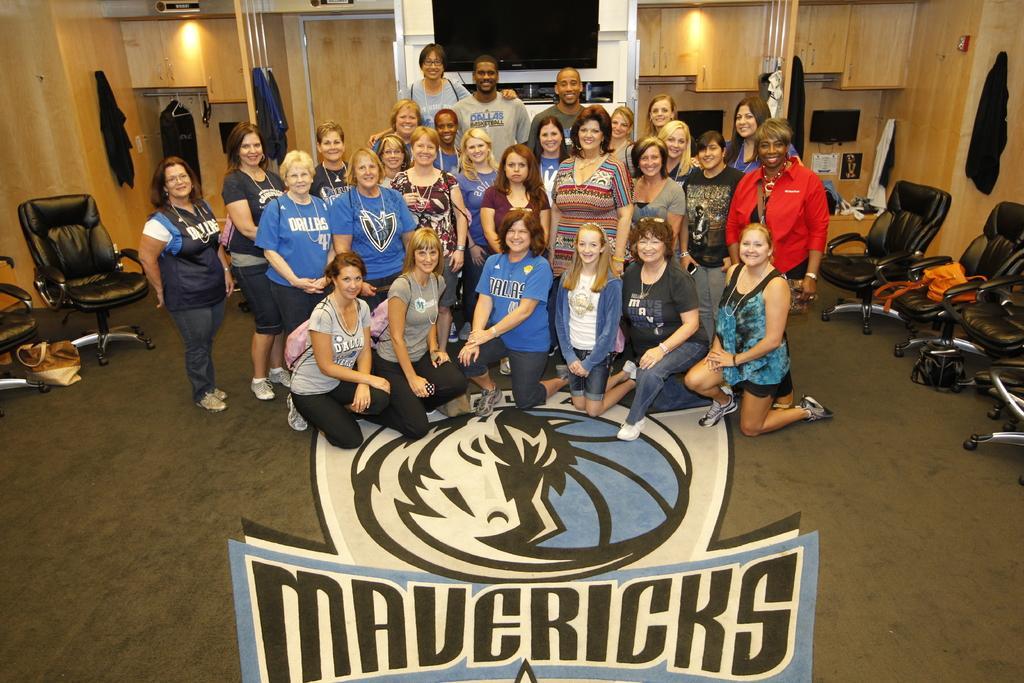Describe this image in one or two sentences. In this image there are group of people in the room. There is a chair and the bag on the floor. At the background there is a television and a light and a rack on a wooden wall. 